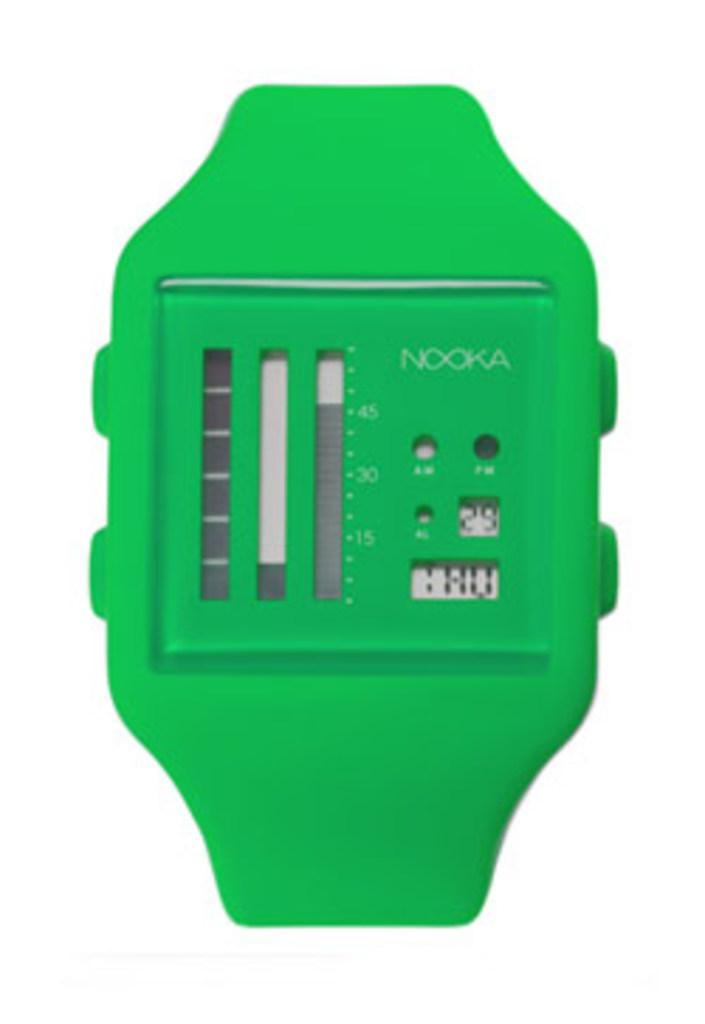<image>
Create a compact narrative representing the image presented. a watch face that is green and says 'nooka' on it and says 29 on it as well 